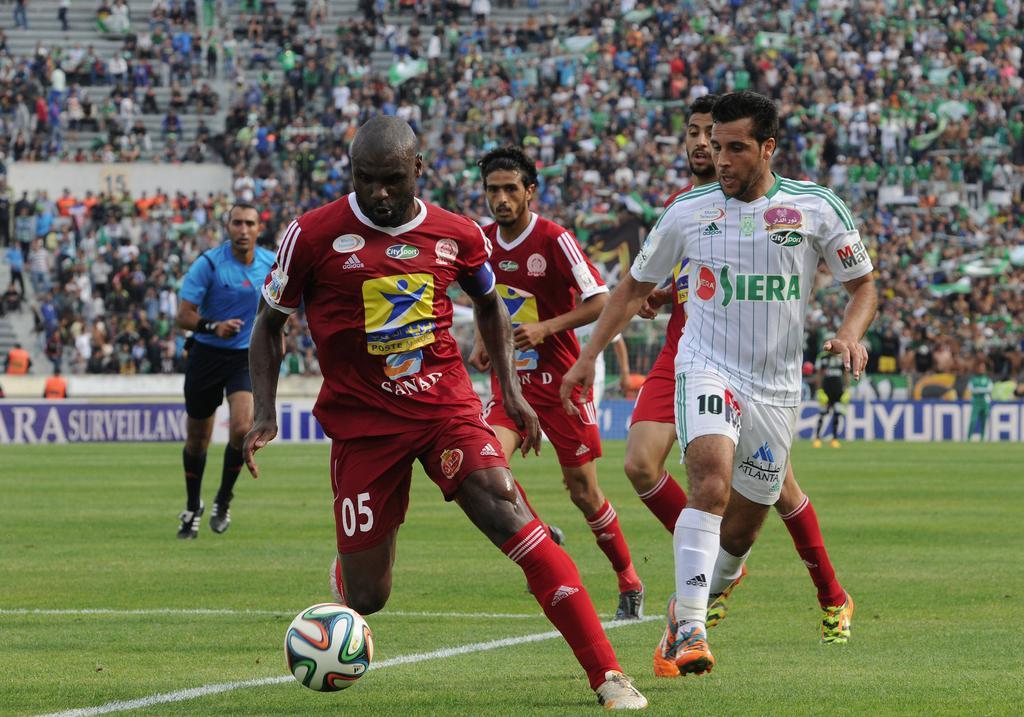Could you give a brief overview of what you see in this image? In the center we can see some players were playing football. And coming to the background we can see group of people were sitting and watching the game. 